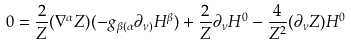Convert formula to latex. <formula><loc_0><loc_0><loc_500><loc_500>0 = \frac { 2 } { Z } ( \nabla ^ { \alpha } Z ) ( - g _ { \beta ( \alpha } \partial _ { \nu ) } H ^ { \beta } ) + \frac { 2 } { Z } \partial _ { \nu } H ^ { 0 } - \frac { 4 } { Z ^ { 2 } } ( \partial _ { \nu } Z ) H ^ { 0 }</formula> 